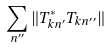Convert formula to latex. <formula><loc_0><loc_0><loc_500><loc_500>\sum _ { n ^ { \prime \prime } } \| T _ { k n ^ { \prime } } ^ { * } T _ { k n ^ { \prime \prime } } \|</formula> 